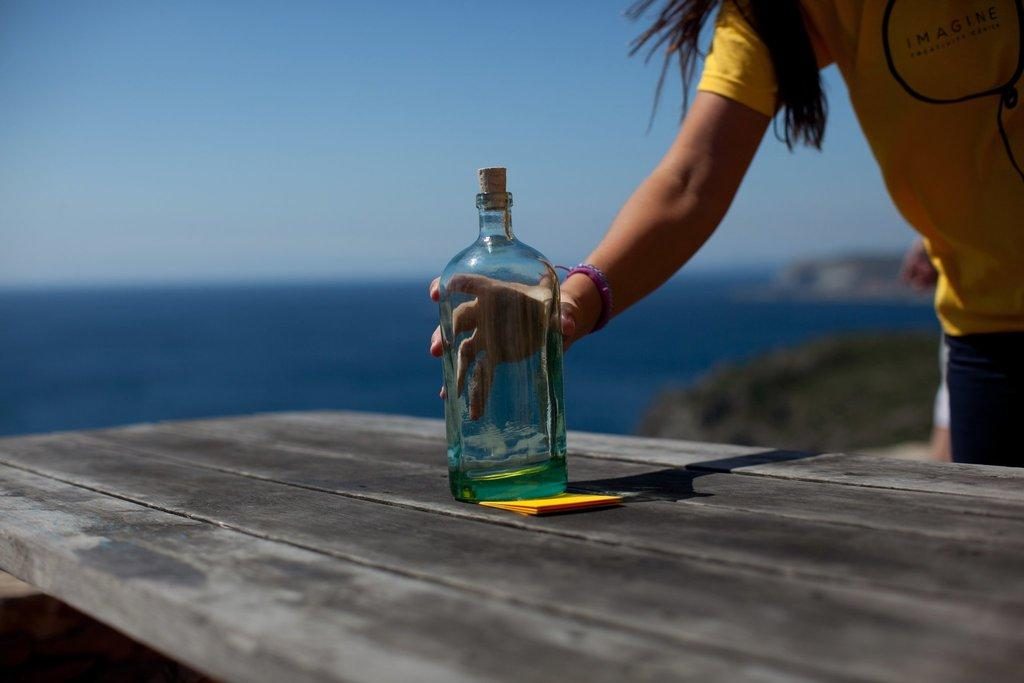What is the main subject of the image? The main subject of the image is a person. What is the person holding in the image? The person is holding a glass bottle. Where is the glass bottle located in the image? The glass bottle is on a table. What is the value of the country depicted on the glass bottle in the image? There is no country or value depicted on the glass bottle in the image. 